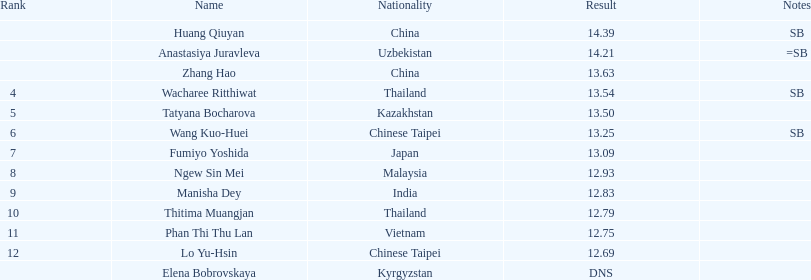How many individuals had a score of under 1 6. 